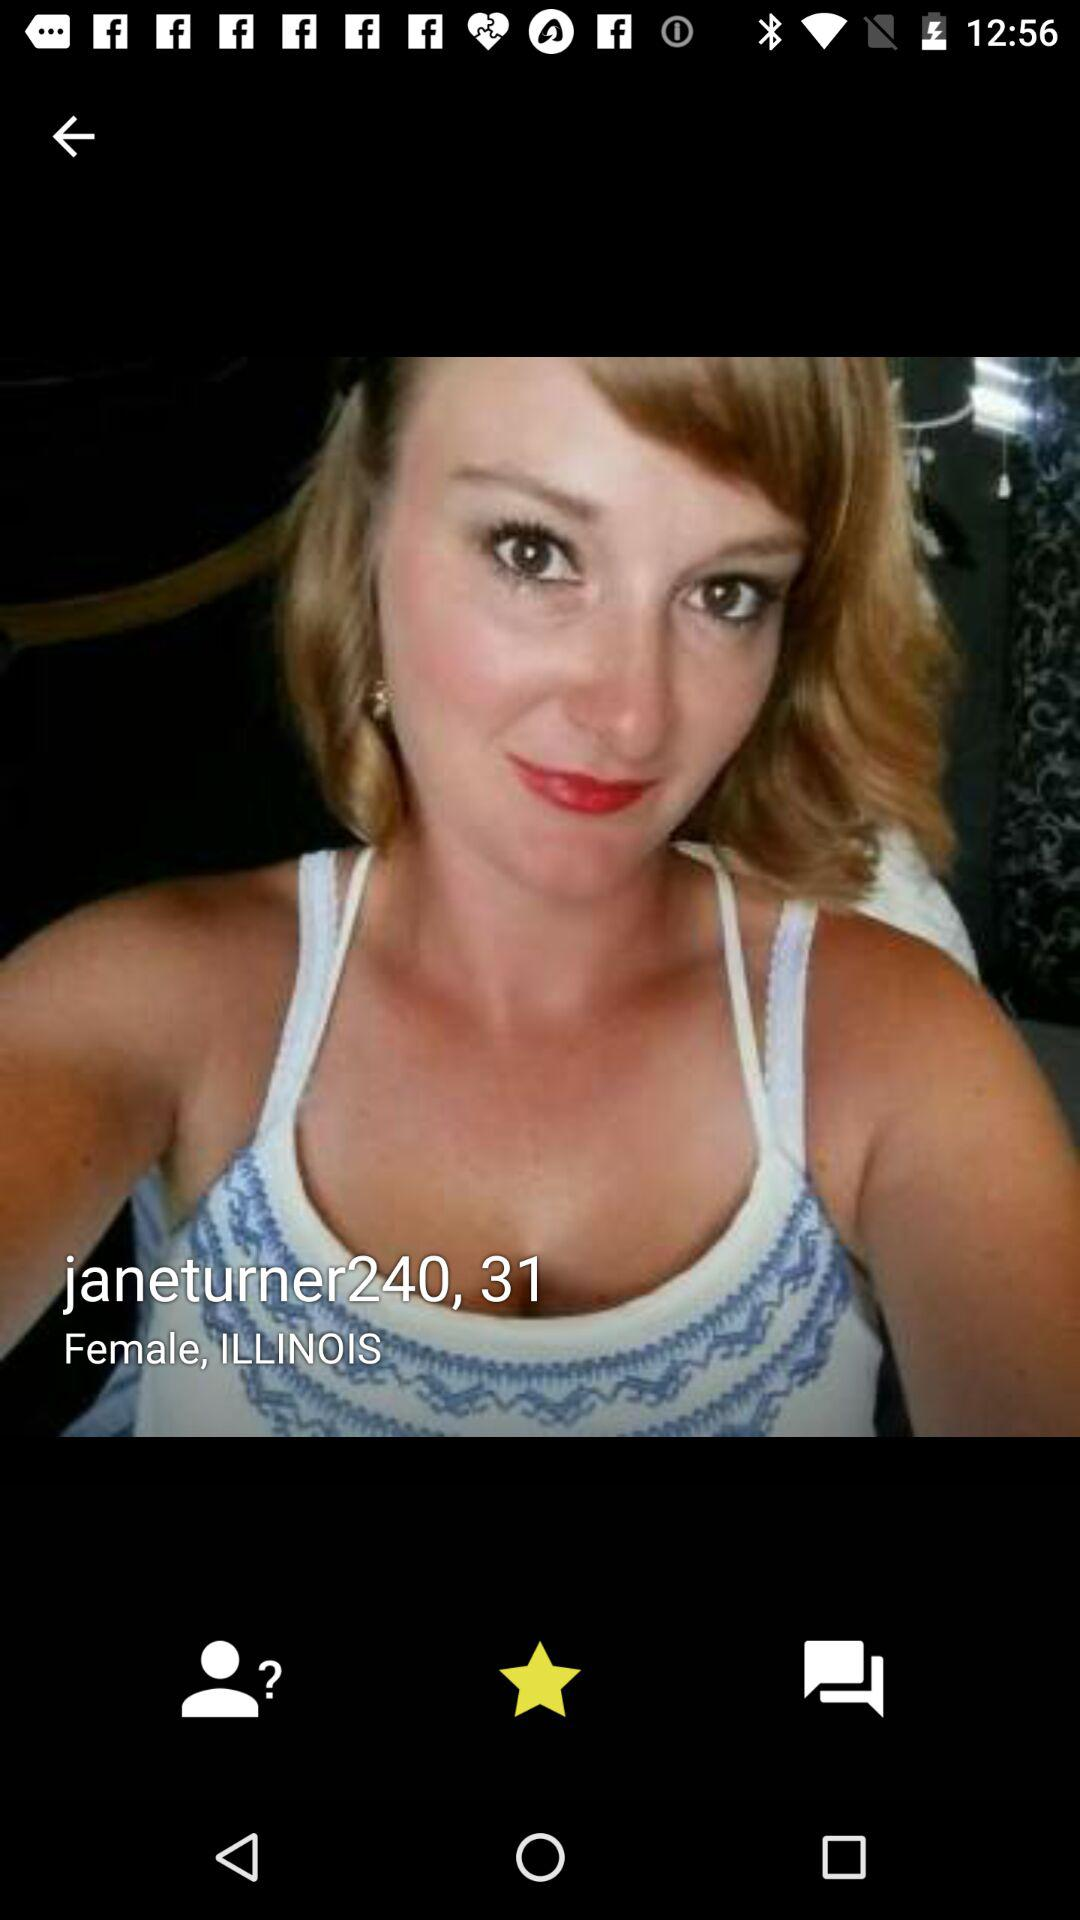What is the location? The location is Illinois. 